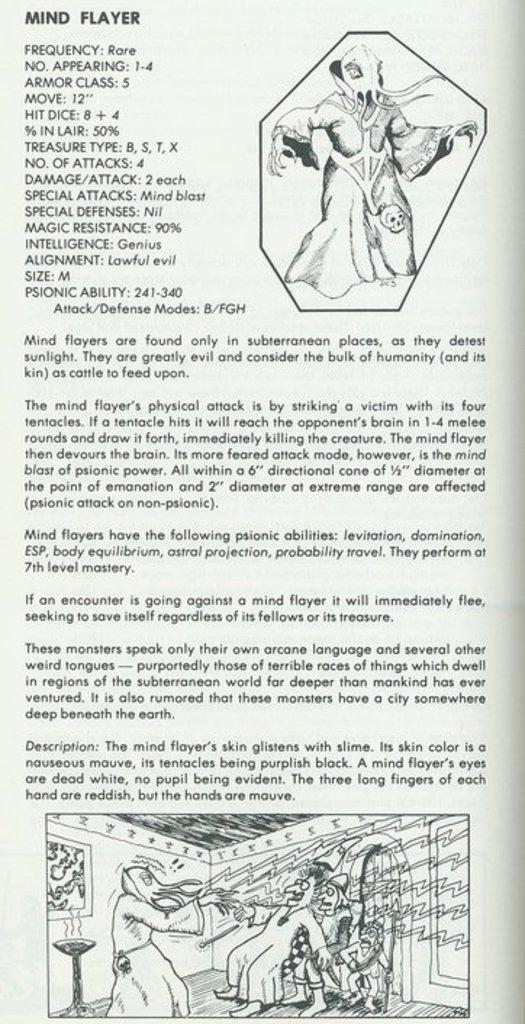What is present in the image that contains information or visuals? There is a paper in the image that contains text and pictures. What type of content can be found on the paper? The paper contains both text and pictures. What type of flower is growing on the paper in the image? There is no flower present on the paper in the image; it contains text and pictures. What material is the brass object made of in the image? There is no brass object present in the image. 